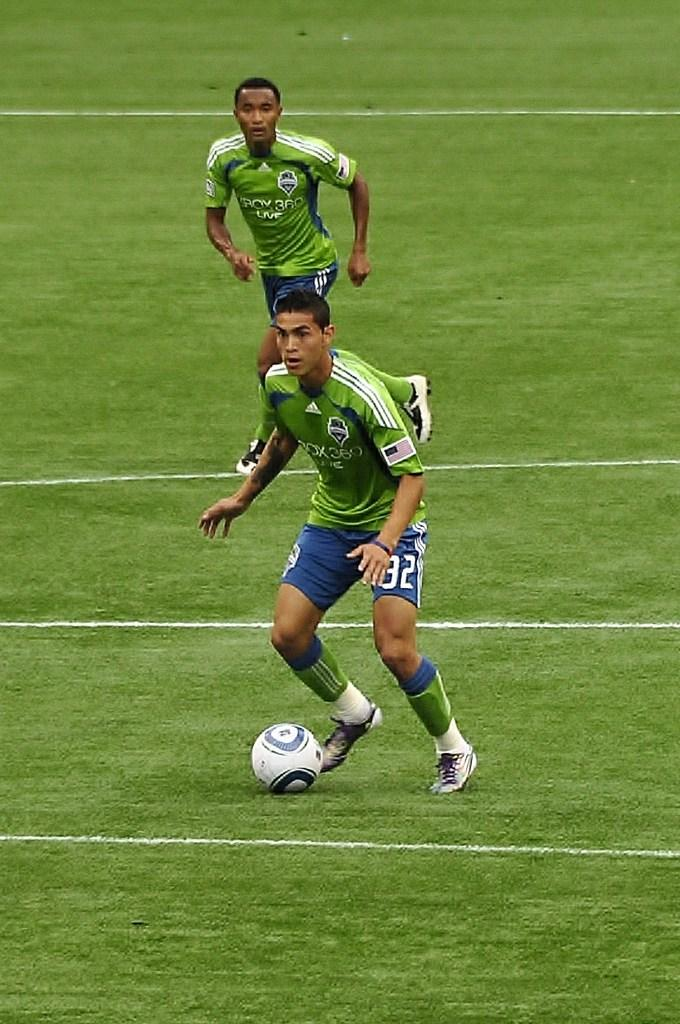How many players are present in the image? There are two players in the image. What are the players doing in the image? The players are playing with a ball. Where is the setting of the image? The setting is a playground. What type of journey does the ball take in the image? The ball does not take a journey in the image; it is being played with by the two players. What memories might the players have while playing in the image? The provided facts do not give any information about the players' memories, so it cannot be determined from the image. 